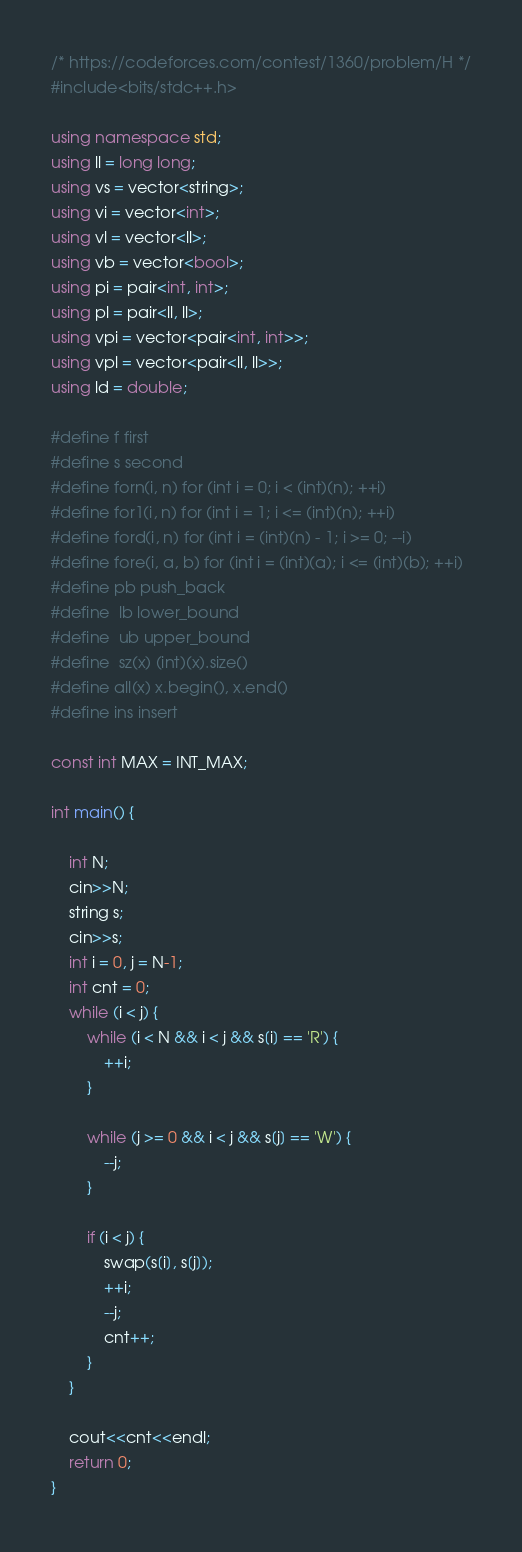<code> <loc_0><loc_0><loc_500><loc_500><_C++_>/* https://codeforces.com/contest/1360/problem/H */
#include<bits/stdc++.h>

using namespace std;
using ll = long long;
using vs = vector<string>;
using vi = vector<int>;
using vl = vector<ll>;
using vb = vector<bool>;
using pi = pair<int, int>;
using pl = pair<ll, ll>;
using vpi = vector<pair<int, int>>;
using vpl = vector<pair<ll, ll>>;
using ld = double;

#define f first
#define s second 
#define forn(i, n) for (int i = 0; i < (int)(n); ++i)
#define for1(i, n) for (int i = 1; i <= (int)(n); ++i)
#define ford(i, n) for (int i = (int)(n) - 1; i >= 0; --i)
#define fore(i, a, b) for (int i = (int)(a); i <= (int)(b); ++i)
#define pb push_back
#define	lb lower_bound
#define	ub upper_bound
#define	sz(x) (int)(x).size()
#define all(x) x.begin(), x.end()
#define ins insert

const int MAX = INT_MAX;

int main() {
	
	int N;
	cin>>N;
	string s;
	cin>>s;
	int i = 0, j = N-1;
	int cnt = 0;
	while (i < j) {
		while (i < N && i < j && s[i] == 'R') {
			++i;
		}

		while (j >= 0 && i < j && s[j] == 'W') {
			--j;
		}

		if (i < j) {
			swap(s[i], s[j]);
			++i;
			--j;
			cnt++;
		}
	}

	cout<<cnt<<endl;
	return 0;
}
</code> 